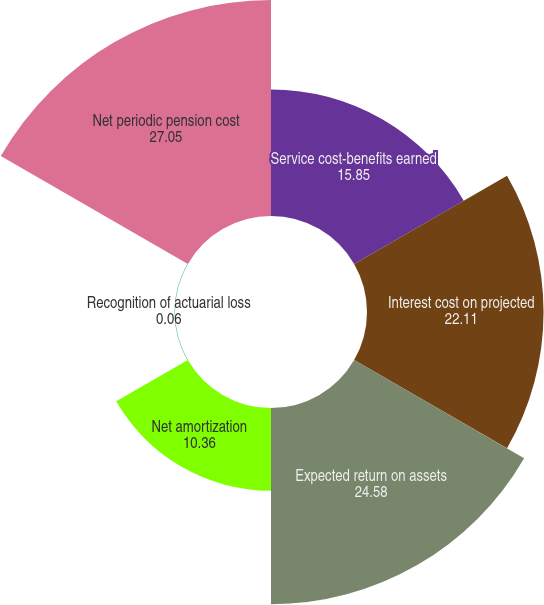<chart> <loc_0><loc_0><loc_500><loc_500><pie_chart><fcel>Service cost-benefits earned<fcel>Interest cost on projected<fcel>Expected return on assets<fcel>Net amortization<fcel>Recognition of actuarial loss<fcel>Net periodic pension cost<nl><fcel>15.85%<fcel>22.11%<fcel>24.58%<fcel>10.36%<fcel>0.06%<fcel>27.05%<nl></chart> 